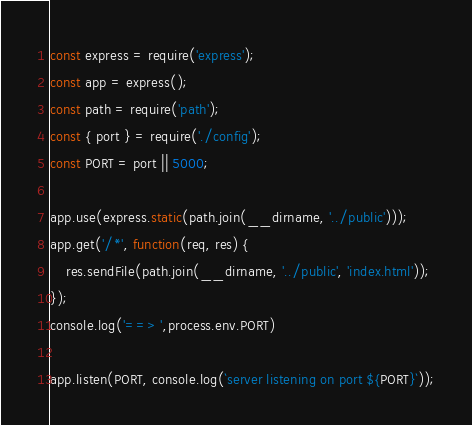<code> <loc_0><loc_0><loc_500><loc_500><_JavaScript_>const express = require('express');
const app = express();
const path = require('path');
const { port } = require('./config');
const PORT = port || 5000;

app.use(express.static(path.join(__dirname, '../public')));
app.get('/*', function(req, res) {
    res.sendFile(path.join(__dirname, '../public', 'index.html'));
});
console.log('==> ',process.env.PORT)

app.listen(PORT, console.log(`server listening on port ${PORT}`));</code> 